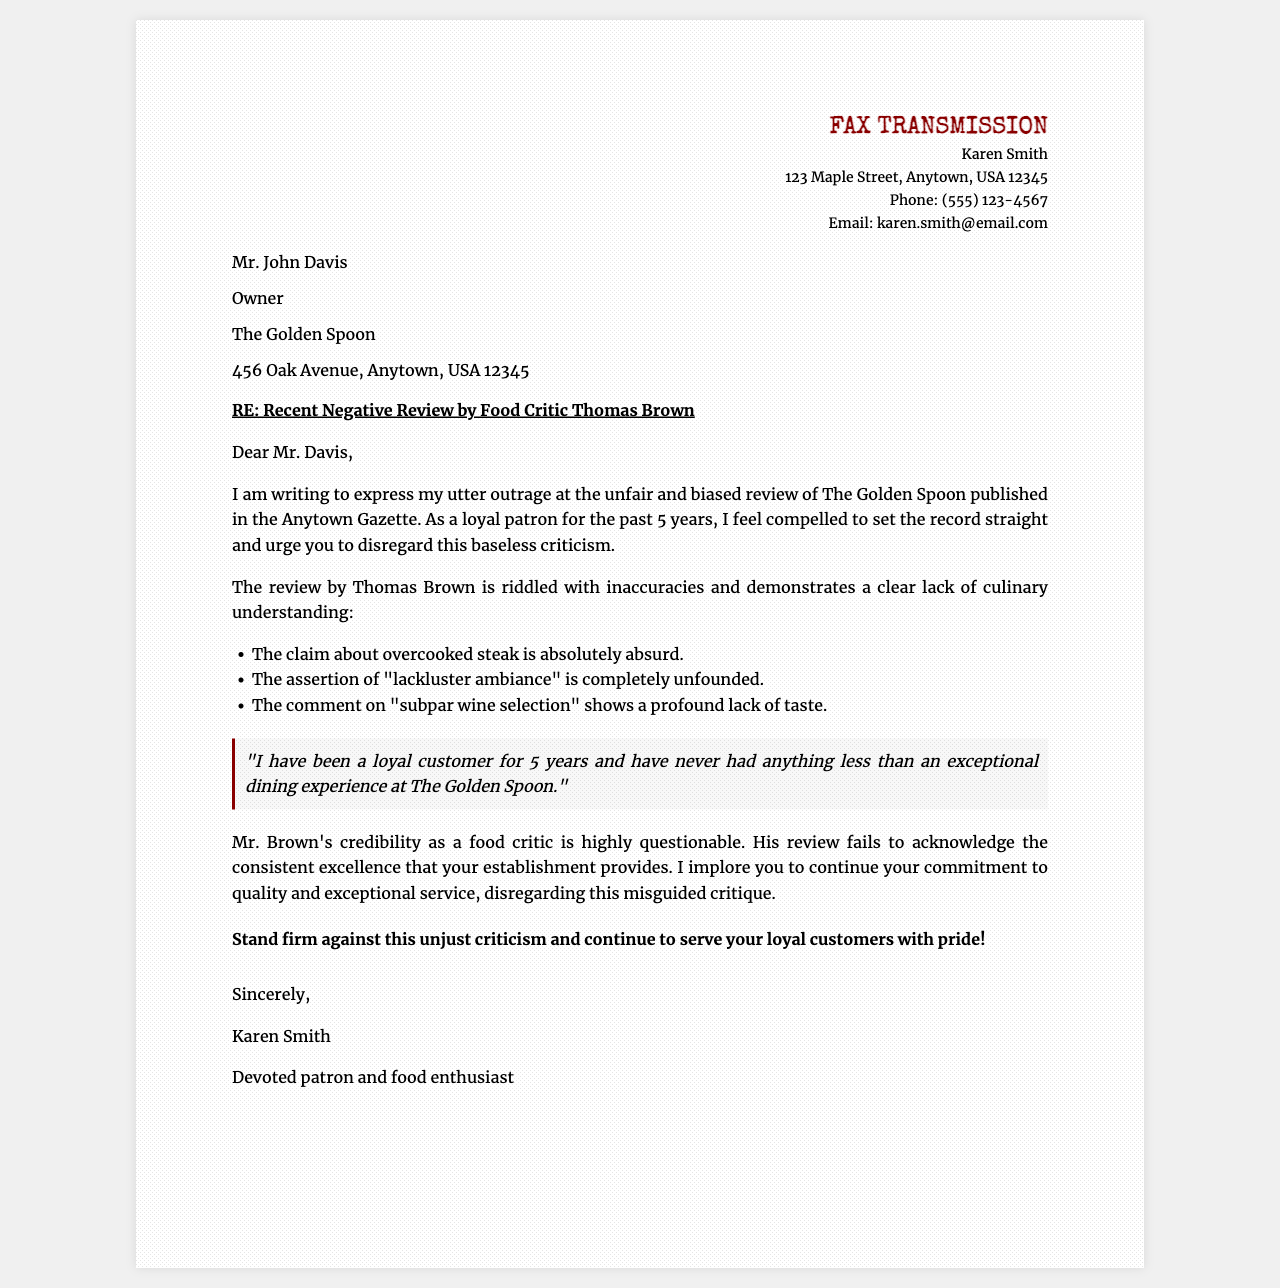What is the name of the sender? The sender's name is mentioned in the fax header, which indicates the author of the letter.
Answer: Karen Smith Who is the recipient of the fax? The document contains the recipient's name, identifying who the fax is directed to.
Answer: Mr. John Davis What is the subject of the fax? The subject line states the main topic that the fax addresses, capturing its essence.
Answer: RE: Recent Negative Review by Food Critic Thomas Brown How many years has the sender been a patron? The content mentions the duration of loyalty of the sender to the restaurant, providing a personal touch.
Answer: 5 years What is one claim made by the reviewer Thomas Brown? The fax provides specific critiques made by the reviewer, which the sender disputes.
Answer: Overcooked steak Why does the sender consider the review baseless? The sender outlines various inaccuracies in the review which contributes to their stance.
Answer: Riddled with inaccuracies What does the sender urge the restaurant owner to do? The letter contains a clear request made by the sender towards the recipient regarding their response.
Answer: Disregard this baseless criticism What type of document is this? The format and intention behind the content of the document guide this identification.
Answer: Fax What is the tone of the letter? The choice of words and expressions throughout the letter combine to convey a specific attitude or emotion.
Answer: Outrage 